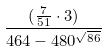Convert formula to latex. <formula><loc_0><loc_0><loc_500><loc_500>\frac { ( \frac { 7 } { 5 1 } \cdot 3 ) } { 4 6 4 - 4 8 0 ^ { \sqrt { 8 6 } } }</formula> 